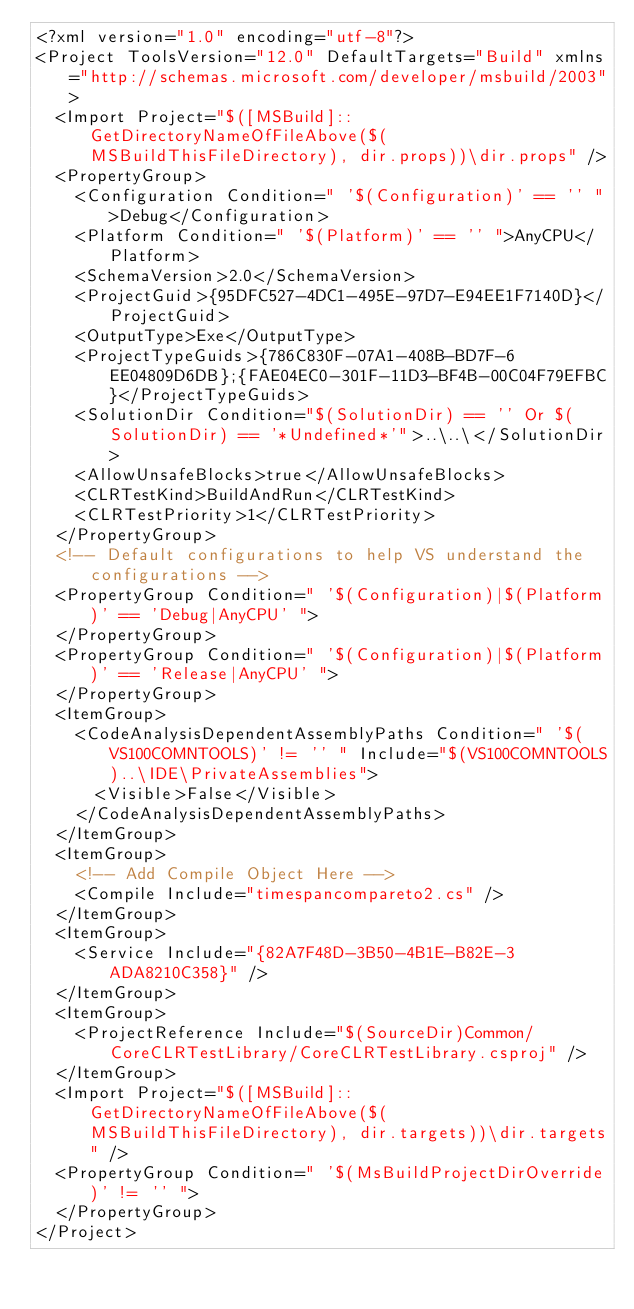Convert code to text. <code><loc_0><loc_0><loc_500><loc_500><_XML_><?xml version="1.0" encoding="utf-8"?>
<Project ToolsVersion="12.0" DefaultTargets="Build" xmlns="http://schemas.microsoft.com/developer/msbuild/2003">
  <Import Project="$([MSBuild]::GetDirectoryNameOfFileAbove($(MSBuildThisFileDirectory), dir.props))\dir.props" />
  <PropertyGroup>
    <Configuration Condition=" '$(Configuration)' == '' ">Debug</Configuration>
    <Platform Condition=" '$(Platform)' == '' ">AnyCPU</Platform>
    <SchemaVersion>2.0</SchemaVersion>
    <ProjectGuid>{95DFC527-4DC1-495E-97D7-E94EE1F7140D}</ProjectGuid>
    <OutputType>Exe</OutputType>
    <ProjectTypeGuids>{786C830F-07A1-408B-BD7F-6EE04809D6DB};{FAE04EC0-301F-11D3-BF4B-00C04F79EFBC}</ProjectTypeGuids>
    <SolutionDir Condition="$(SolutionDir) == '' Or $(SolutionDir) == '*Undefined*'">..\..\</SolutionDir>
    <AllowUnsafeBlocks>true</AllowUnsafeBlocks>
    <CLRTestKind>BuildAndRun</CLRTestKind>
    <CLRTestPriority>1</CLRTestPriority>
  </PropertyGroup>
  <!-- Default configurations to help VS understand the configurations -->
  <PropertyGroup Condition=" '$(Configuration)|$(Platform)' == 'Debug|AnyCPU' ">
  </PropertyGroup>
  <PropertyGroup Condition=" '$(Configuration)|$(Platform)' == 'Release|AnyCPU' ">
  </PropertyGroup>
  <ItemGroup>
    <CodeAnalysisDependentAssemblyPaths Condition=" '$(VS100COMNTOOLS)' != '' " Include="$(VS100COMNTOOLS)..\IDE\PrivateAssemblies">
      <Visible>False</Visible>
    </CodeAnalysisDependentAssemblyPaths>
  </ItemGroup>
  <ItemGroup>
    <!-- Add Compile Object Here -->
    <Compile Include="timespancompareto2.cs" />
  </ItemGroup>
  <ItemGroup>
    <Service Include="{82A7F48D-3B50-4B1E-B82E-3ADA8210C358}" />
  </ItemGroup>
  <ItemGroup>
    <ProjectReference Include="$(SourceDir)Common/CoreCLRTestLibrary/CoreCLRTestLibrary.csproj" />
  </ItemGroup>
  <Import Project="$([MSBuild]::GetDirectoryNameOfFileAbove($(MSBuildThisFileDirectory), dir.targets))\dir.targets" />
  <PropertyGroup Condition=" '$(MsBuildProjectDirOverride)' != '' ">
  </PropertyGroup>
</Project>

</code> 